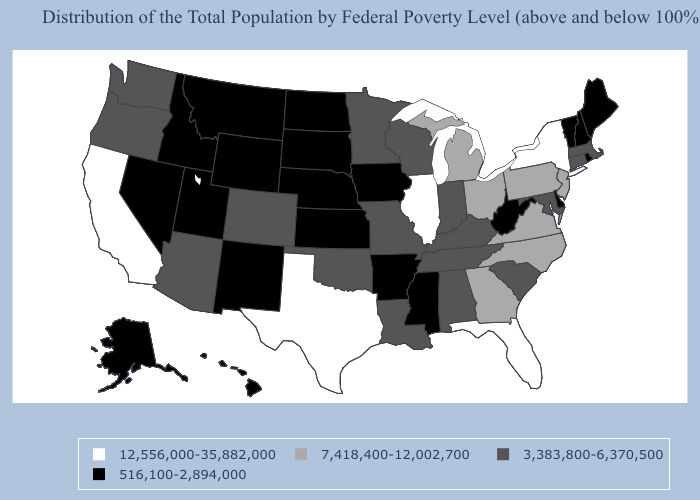Which states hav the highest value in the MidWest?
Answer briefly. Illinois. Does Illinois have a higher value than Texas?
Quick response, please. No. Which states have the lowest value in the USA?
Quick response, please. Alaska, Arkansas, Delaware, Hawaii, Idaho, Iowa, Kansas, Maine, Mississippi, Montana, Nebraska, Nevada, New Hampshire, New Mexico, North Dakota, Rhode Island, South Dakota, Utah, Vermont, West Virginia, Wyoming. Among the states that border Utah , does Arizona have the highest value?
Keep it brief. Yes. What is the value of Pennsylvania?
Concise answer only. 7,418,400-12,002,700. Does Arkansas have the lowest value in the USA?
Answer briefly. Yes. What is the value of Illinois?
Quick response, please. 12,556,000-35,882,000. What is the value of Nebraska?
Give a very brief answer. 516,100-2,894,000. What is the highest value in the USA?
Be succinct. 12,556,000-35,882,000. Name the states that have a value in the range 3,383,800-6,370,500?
Give a very brief answer. Alabama, Arizona, Colorado, Connecticut, Indiana, Kentucky, Louisiana, Maryland, Massachusetts, Minnesota, Missouri, Oklahoma, Oregon, South Carolina, Tennessee, Washington, Wisconsin. Does Connecticut have the same value as Florida?
Give a very brief answer. No. What is the value of New Mexico?
Answer briefly. 516,100-2,894,000. Among the states that border Minnesota , which have the lowest value?
Short answer required. Iowa, North Dakota, South Dakota. Name the states that have a value in the range 3,383,800-6,370,500?
Answer briefly. Alabama, Arizona, Colorado, Connecticut, Indiana, Kentucky, Louisiana, Maryland, Massachusetts, Minnesota, Missouri, Oklahoma, Oregon, South Carolina, Tennessee, Washington, Wisconsin. 